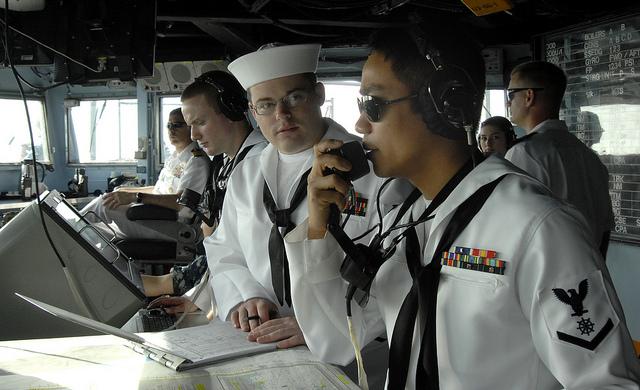How many are wearing hats?
Keep it brief. 1. What military branch are these people in?
Write a very short answer. Navy. How many sailors are in this image?
Give a very brief answer. 6. 